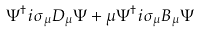<formula> <loc_0><loc_0><loc_500><loc_500>\Psi ^ { \dagger } i \sigma _ { \mu } D _ { \mu } \Psi + \mu \Psi ^ { \dagger } i \sigma _ { \mu } B _ { \mu } \Psi</formula> 